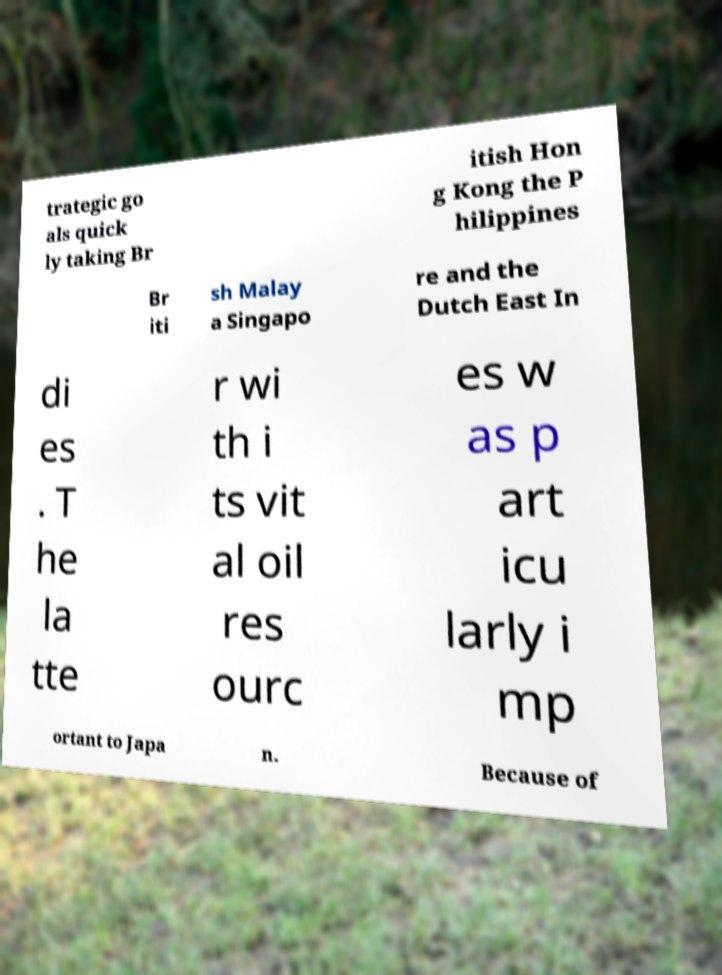For documentation purposes, I need the text within this image transcribed. Could you provide that? trategic go als quick ly taking Br itish Hon g Kong the P hilippines Br iti sh Malay a Singapo re and the Dutch East In di es . T he la tte r wi th i ts vit al oil res ourc es w as p art icu larly i mp ortant to Japa n. Because of 